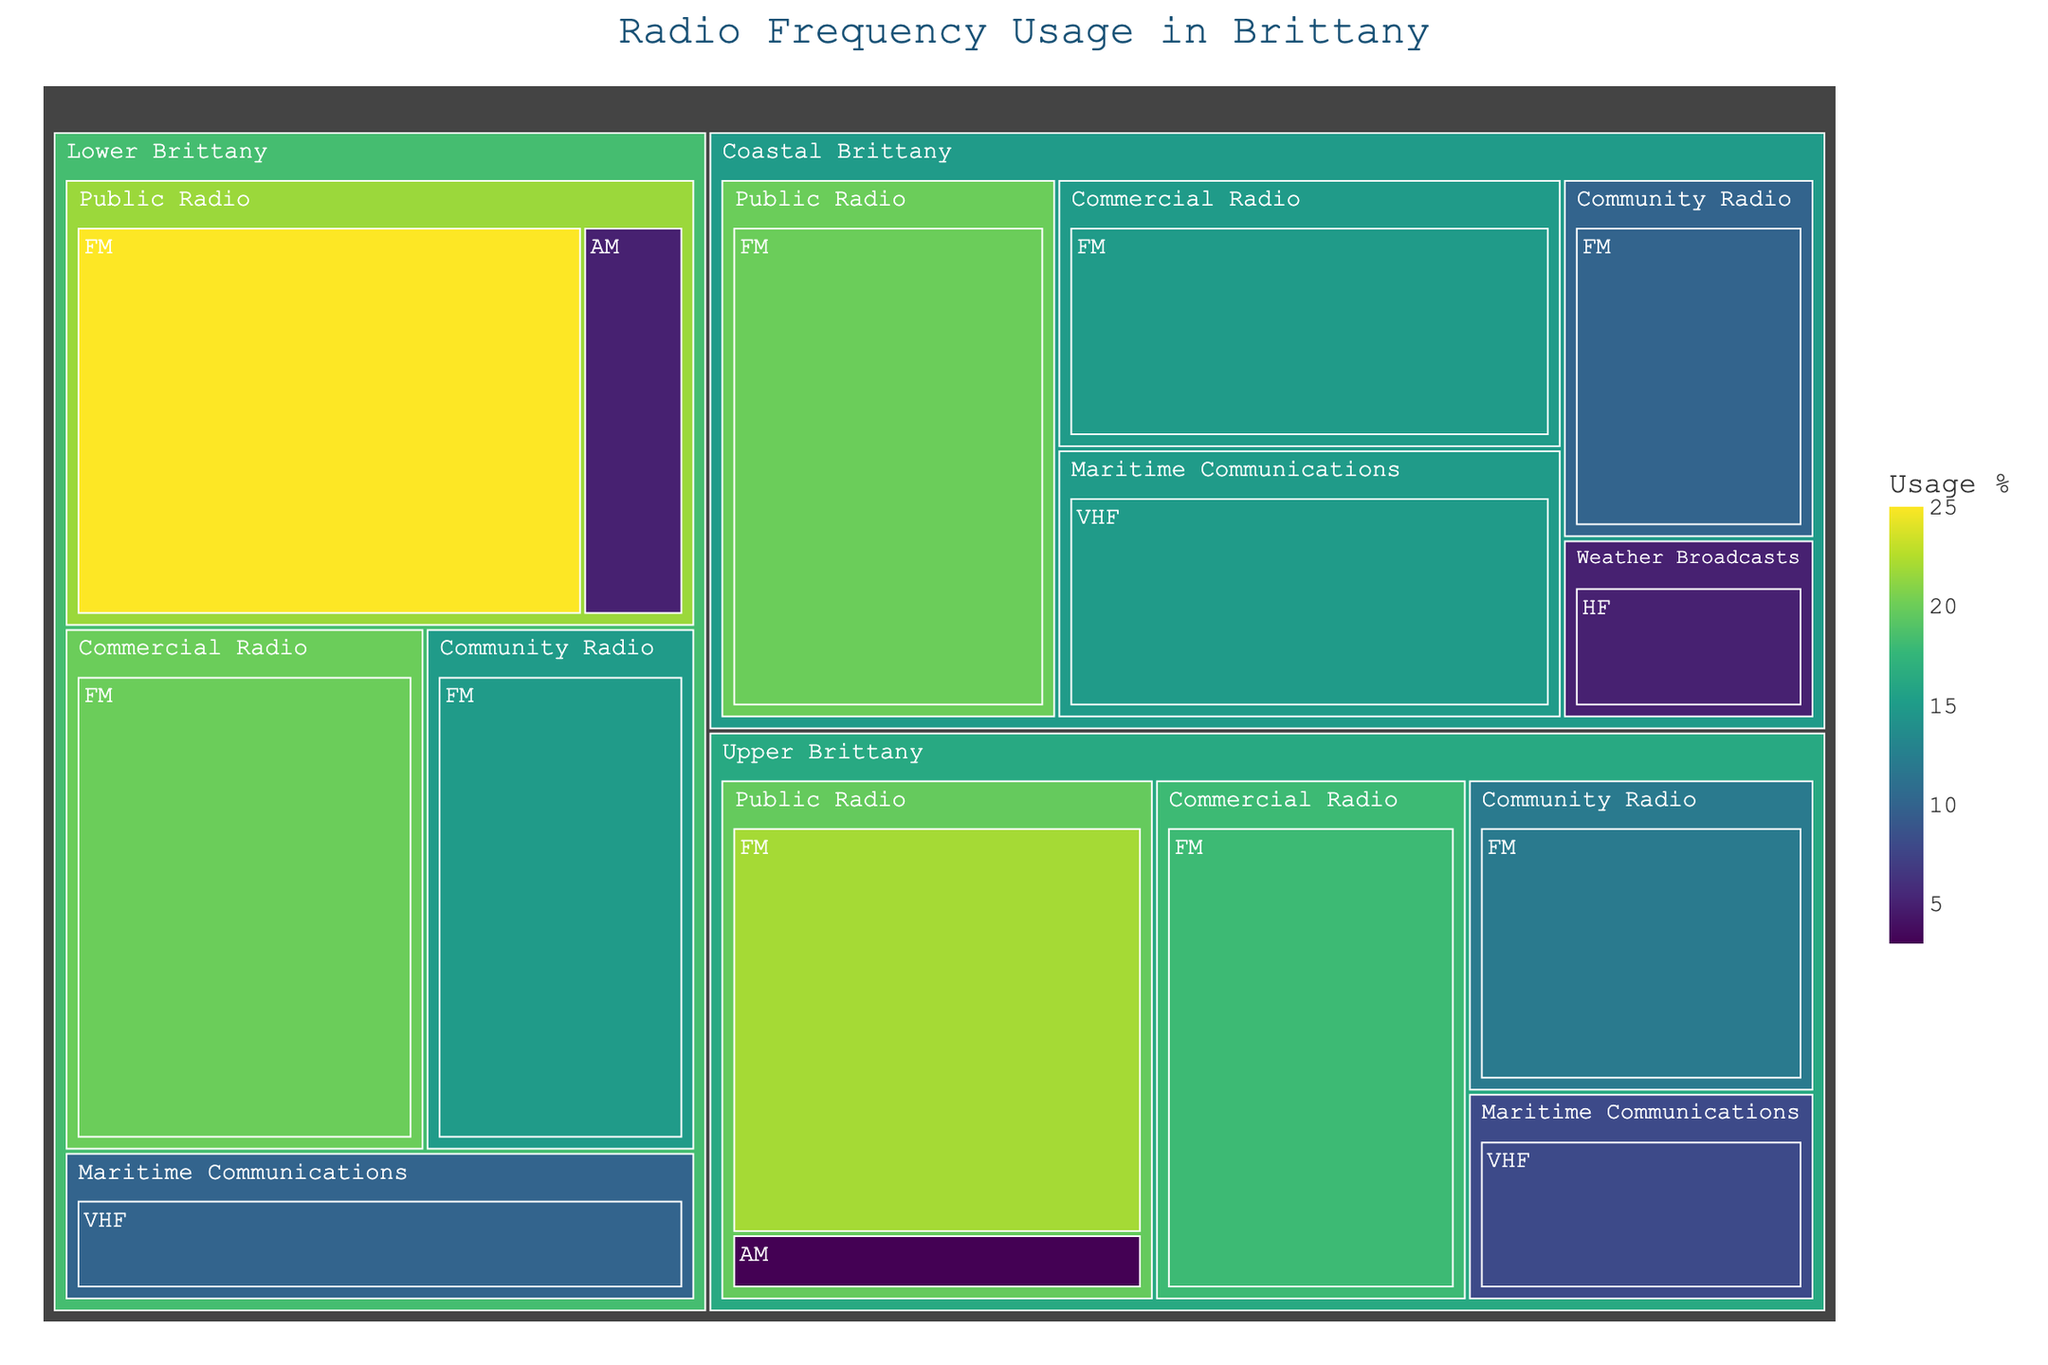What is the title of the treemap? The title of a figure is usually displayed at the top or near the top of the plot. Here, the title is "Radio Frequency Usage in Brittany"
Answer: Radio Frequency Usage in Brittany Which region has the highest usage percentage for public radio on FM? To answer this, look at the size of the sections labeled "Public Radio" within the "FM" band for each region. In this case, Lower Brittany shows the largest section for this category with a 25% usage.
Answer: Lower Brittany What is the combined usage percentage of commercial radio on FM in Upper and Coastal Brittany? Sum the percentage usage of commercial radio on FM for Upper and Coastal Brittany: Upper Brittany has 18% and Coastal Brittany has 15%. 18 + 15 = 33
Answer: 33% Which region has the least usage percentage for public radio on AM? Compare the size of the sections labeled "Public Radio" on the "AM" band in each region. Upper Brittany has the smallest section with 3%.
Answer: Upper Brittany How does the usage percentage for community radio on FM in Lower Brittany compare to Upper Brittany? Look at the labels for "Community Radio" on the "FM" band for both regions. Lower Brittany has 15% while Upper Brittany has 12%, so Lower Brittany has a higher percentage.
Answer: Lower Brittany has a higher percentage Which frequency band has the highest percentage usage for Maritime Communications in Coastal Brittany? In Coastal Brittany, the Maritime Communications category shows two possible bands: VHF with 15% and there is no AM band usage. So VHF has the highest percentage.
Answer: VHF What is the average usage percentage for community radio on FM across all regions? Add the percentages for community radio on FM in each region: Lower Brittany (15%), Upper Brittany (12%), and Coastal Brittany (10%). Then divide by the number of regions (3). (15 + 12 + 10) / 3 = 12.33
Answer: 12.33% If the total usage percentage for all broadcast types within Coastal Brittany is 65%, what percentage is occupied by non-radio communications? In Coastal Brittany, Maritime Communications on VHF has 15%, and Weather Broadcasts on HF has 5%. Summing these, 15 + 5 = 20. To find the percentage for non-radio communications, subtract this from 100. 100 - 65 = 35%
Answer: 35% Which has a greater usage percentage in Lower Brittany: public radio on AM or maritime communications on VHF? Compare the percentages for public radio on AM (5%) and maritime communications on VHF (10%). Maritime communications on VHF has a greater percentage.
Answer: Maritime communications on VHF What is the total percentage usage for all frequency bands in Upper Brittany? Sum all the usage percentages for Upper Brittany: Public Radio on FM (22%), Commercial Radio on FM (18%), Community Radio on FM (12%), Public Radio on AM (3%), and Maritime Communications on VHF (8%). 22 + 18 + 12 + 3 + 8 = 63%
Answer: 63% 